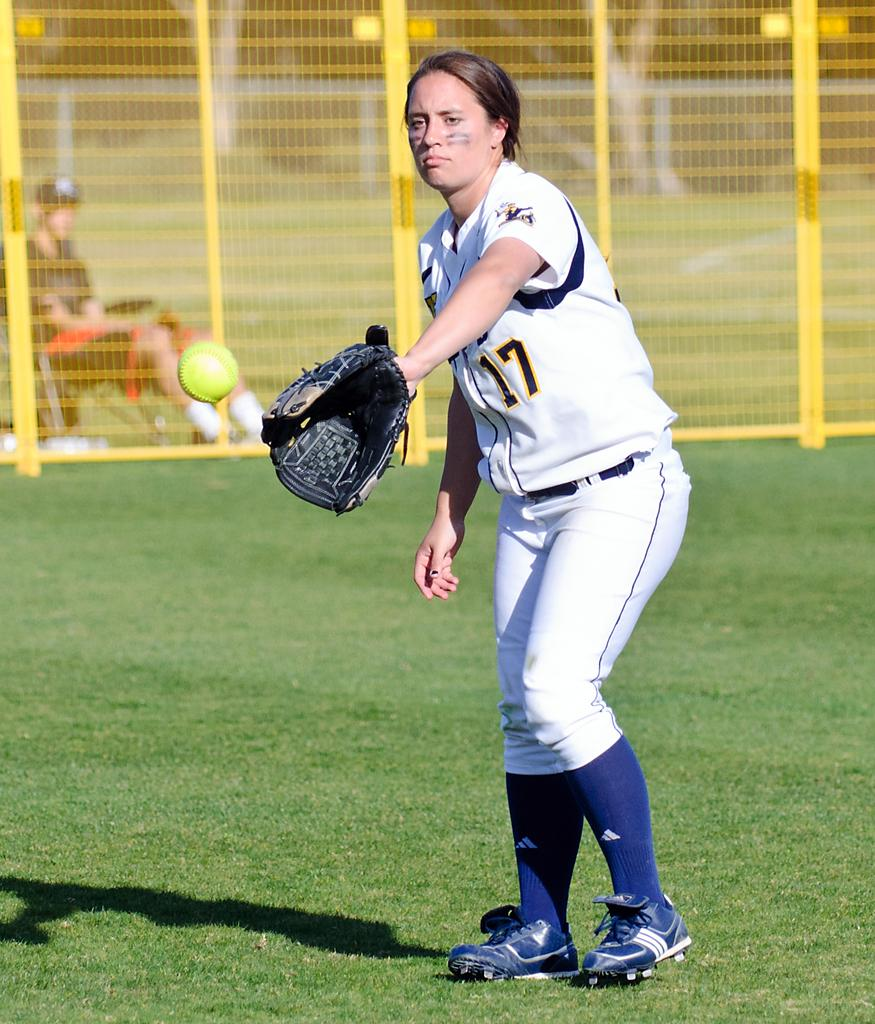<image>
Share a concise interpretation of the image provided. The girl pictured is wearing a number 17 top. 